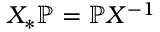<formula> <loc_0><loc_0><loc_500><loc_500>X _ { * } \mathbb { P } = \mathbb { P } X ^ { - 1 }</formula> 